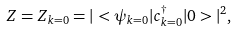<formula> <loc_0><loc_0><loc_500><loc_500>Z = Z _ { k = 0 } = | < \psi _ { k = 0 } | c ^ { \dagger } _ { k = 0 } | 0 > | ^ { 2 } ,</formula> 